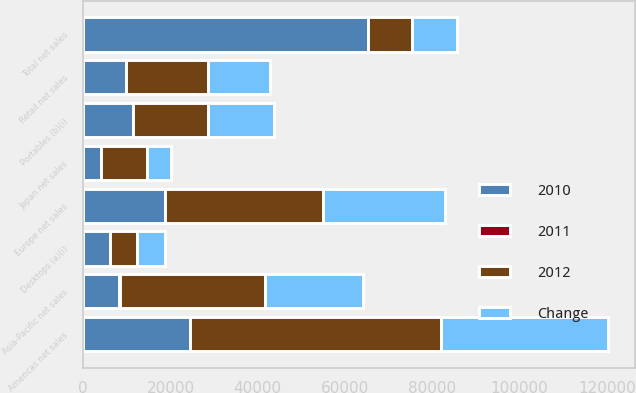Convert chart to OTSL. <chart><loc_0><loc_0><loc_500><loc_500><stacked_bar_chart><ecel><fcel>Americas net sales<fcel>Europe net sales<fcel>Japan net sales<fcel>Asia-Pacific net sales<fcel>Retail net sales<fcel>Total net sales<fcel>Desktops (a)(i)<fcel>Portables (b)(i)<nl><fcel>2012<fcel>57512<fcel>36323<fcel>10571<fcel>33274<fcel>18828<fcel>10184.5<fcel>6040<fcel>17181<nl><fcel>2011<fcel>50<fcel>31<fcel>94<fcel>47<fcel>33<fcel>45<fcel>6<fcel>12<nl><fcel>Change<fcel>38315<fcel>27778<fcel>5437<fcel>22592<fcel>14127<fcel>10184.5<fcel>6439<fcel>15344<nl><fcel>2010<fcel>24498<fcel>18692<fcel>3981<fcel>8256<fcel>9798<fcel>65225<fcel>6201<fcel>11278<nl></chart> 